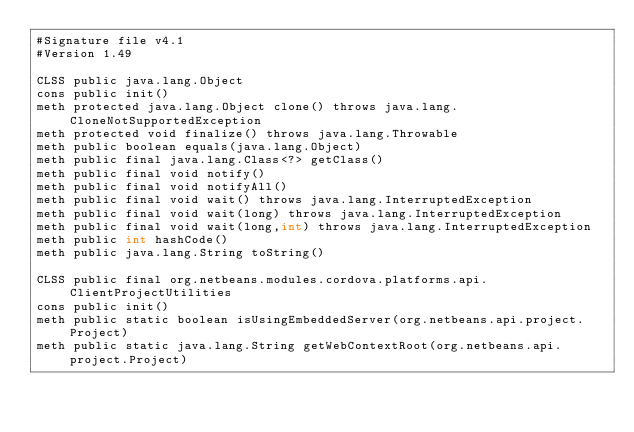<code> <loc_0><loc_0><loc_500><loc_500><_SML_>#Signature file v4.1
#Version 1.49

CLSS public java.lang.Object
cons public init()
meth protected java.lang.Object clone() throws java.lang.CloneNotSupportedException
meth protected void finalize() throws java.lang.Throwable
meth public boolean equals(java.lang.Object)
meth public final java.lang.Class<?> getClass()
meth public final void notify()
meth public final void notifyAll()
meth public final void wait() throws java.lang.InterruptedException
meth public final void wait(long) throws java.lang.InterruptedException
meth public final void wait(long,int) throws java.lang.InterruptedException
meth public int hashCode()
meth public java.lang.String toString()

CLSS public final org.netbeans.modules.cordova.platforms.api.ClientProjectUtilities
cons public init()
meth public static boolean isUsingEmbeddedServer(org.netbeans.api.project.Project)
meth public static java.lang.String getWebContextRoot(org.netbeans.api.project.Project)</code> 